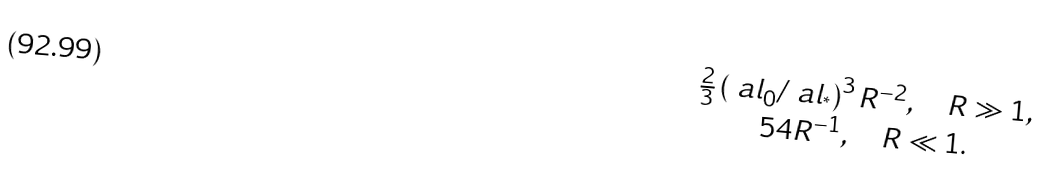<formula> <loc_0><loc_0><loc_500><loc_500>\begin{matrix} \frac { 2 } { 3 } \left ( \ a l _ { 0 } / \ a l _ { ^ { * } } \right ) ^ { 3 } R ^ { - 2 } , \quad R \gg 1 , \\ 5 4 R ^ { - 1 } , \quad R \ll 1 . \end{matrix}</formula> 